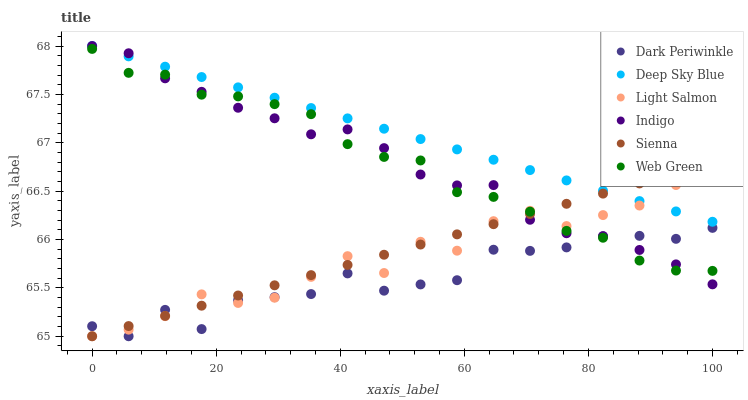Does Dark Periwinkle have the minimum area under the curve?
Answer yes or no. Yes. Does Deep Sky Blue have the maximum area under the curve?
Answer yes or no. Yes. Does Indigo have the minimum area under the curve?
Answer yes or no. No. Does Indigo have the maximum area under the curve?
Answer yes or no. No. Is Deep Sky Blue the smoothest?
Answer yes or no. Yes. Is Dark Periwinkle the roughest?
Answer yes or no. Yes. Is Indigo the smoothest?
Answer yes or no. No. Is Indigo the roughest?
Answer yes or no. No. Does Light Salmon have the lowest value?
Answer yes or no. Yes. Does Indigo have the lowest value?
Answer yes or no. No. Does Deep Sky Blue have the highest value?
Answer yes or no. Yes. Does Web Green have the highest value?
Answer yes or no. No. Is Web Green less than Deep Sky Blue?
Answer yes or no. Yes. Is Deep Sky Blue greater than Dark Periwinkle?
Answer yes or no. Yes. Does Indigo intersect Web Green?
Answer yes or no. Yes. Is Indigo less than Web Green?
Answer yes or no. No. Is Indigo greater than Web Green?
Answer yes or no. No. Does Web Green intersect Deep Sky Blue?
Answer yes or no. No. 